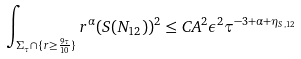<formula> <loc_0><loc_0><loc_500><loc_500>\int _ { \Sigma _ { \tau } \cap \{ r \geq \frac { 9 \tau } { 1 0 } \} } r ^ { \alpha } ( S ( N _ { 1 2 } ) ) ^ { 2 } \leq C A ^ { 2 } \epsilon ^ { 2 } \tau ^ { - 3 + \alpha + \eta _ { S , 1 2 } }</formula> 